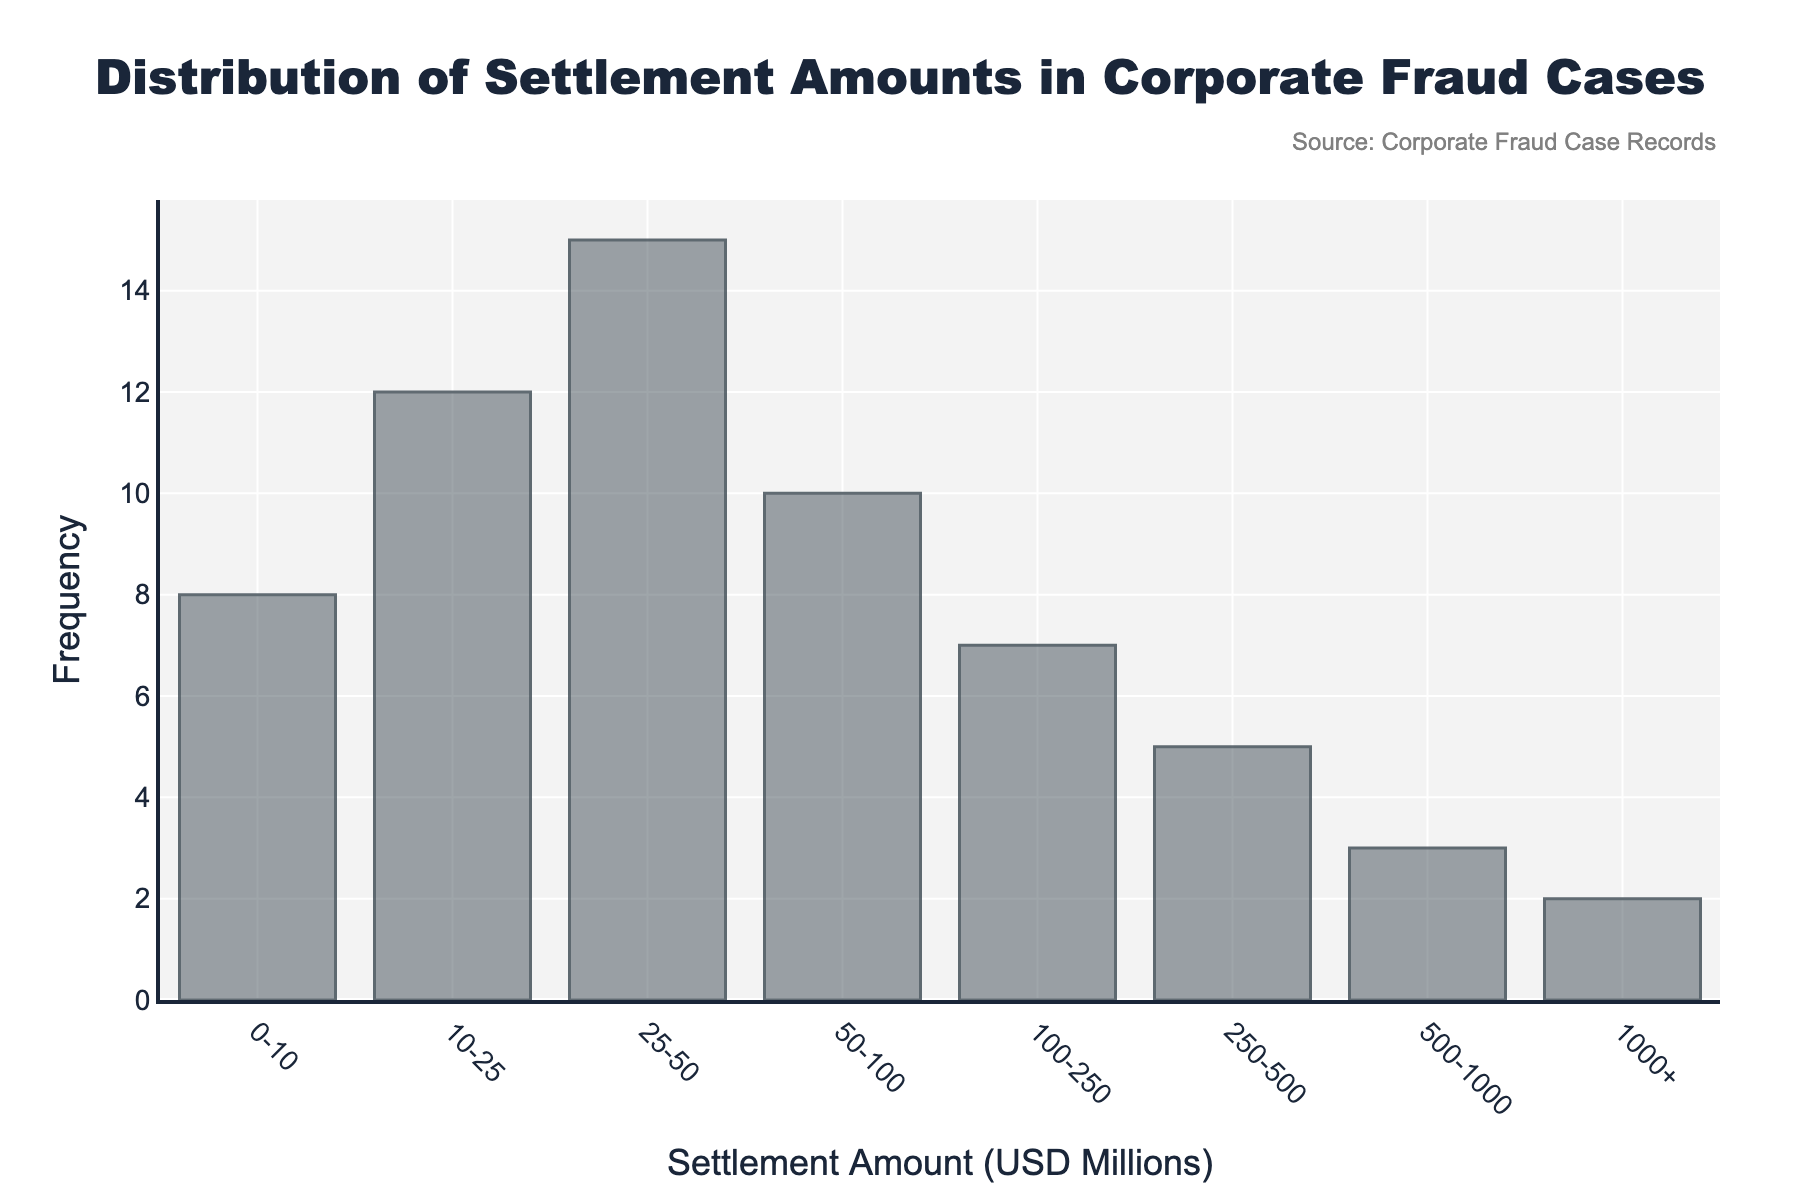What is the title of the histogram? The title of the histogram is usually located at the top of the figure and it provides a summary of what the histogram is about. In this case, it is "Distribution of Settlement Amounts in Corporate Fraud Cases".
Answer: Distribution of Settlement Amounts in Corporate Fraud Cases What is the range of settlement amounts with the highest frequency? By examining the bars on the histogram, the range with the tallest bar represents the highest frequency. In this histogram, the range "25-50" has the highest frequency.
Answer: 25-50 How many settlement cases fall in the range of "0-10" million USD? Each bar's height represents the frequency of settlement cases in that range. For the range "0-10", the frequency is 8.
Answer: 8 Which two settlement ranges have the lowest frequency? Looking at the histogram, the shortest bars represent the lowest frequencies. The ranges "1000+" and "500-1000" each have the lowest frequency with bars of height 2 and 3, respectively.
Answer: 1000+ and 500-1000 What is the total number of settlement cases represented in the histogram? Add up the frequencies of all the settlement ranges: 8 + 12 + 15 + 10 + 7 + 5 + 3 + 2. This gives the total number of settlement cases.
Answer: 62 How does the frequency of the "10-25" range compare to the "50-100" range? By comparing the heights of the bars for "10-25" and "50-100", we can see that the frequency of the "10-25" range (12) is higher than the "50-100" range (10).
Answer: 12 is higher than 10 What is the average settlement amount range frequency? To find the average frequency, sum all frequencies and divide by the number of ranges: (8 + 12 + 15 + 10 + 7 + 5 + 3 + 2) / 8.
Answer: 7.75 Are the majority of settlement cases below 100 million USD? Sum the frequencies of ranges below 100 million USD (0-10, 10-25, 25-50, 50-100) and compare it to the total: 8 + 12 + 15 + 10 = 45. Since the total number of cases is 62, the majority, 45 out of 62, are below 100 million USD.
Answer: Yes Which range experiences a three-fold difference in frequency compared to the "500-1000" range? The frequency in the "500-1000" range is 3. A three-fold difference would be 3 * 3 = 9. The range "50-100" has a frequency of 10, which is close to three times more than the "500-1000" range.
Answer: 50-100 